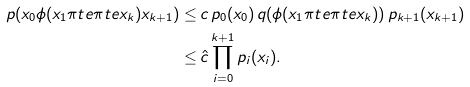<formula> <loc_0><loc_0><loc_500><loc_500>p ( x _ { 0 } \phi ( x _ { 1 } \pi t e \pi t e x _ { k } ) x _ { k + 1 } ) \leq & \, c \, p _ { 0 } ( x _ { 0 } ) \, q ( \phi ( x _ { 1 } \pi t e \pi t e x _ { k } ) ) \, p _ { k + 1 } ( x _ { k + 1 } ) \\ \leq & \, \hat { c } \prod _ { i = 0 } ^ { k + 1 } p _ { i } ( x _ { i } ) .</formula> 